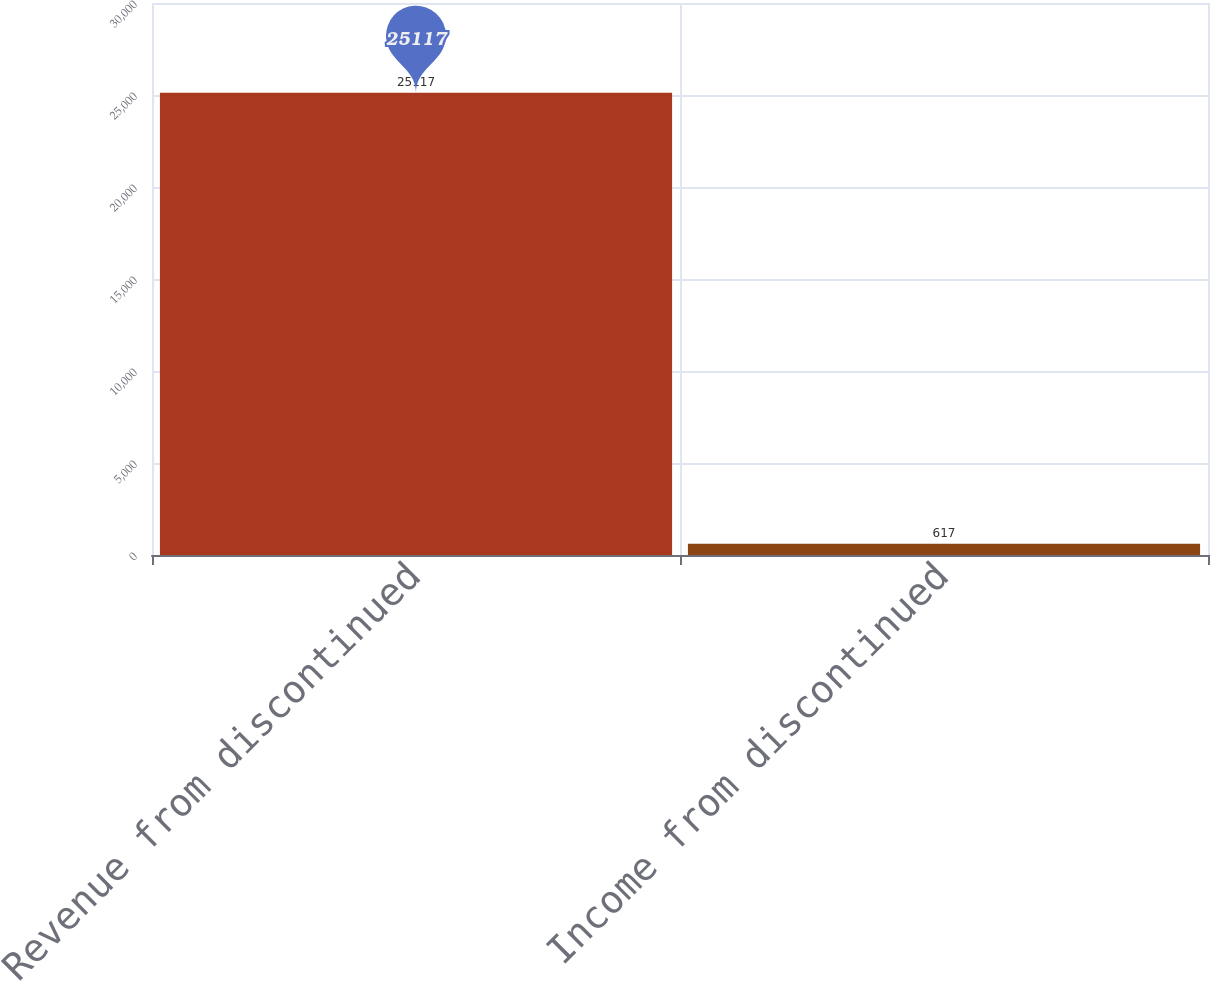Convert chart. <chart><loc_0><loc_0><loc_500><loc_500><bar_chart><fcel>Revenue from discontinued<fcel>Income from discontinued<nl><fcel>25117<fcel>617<nl></chart> 